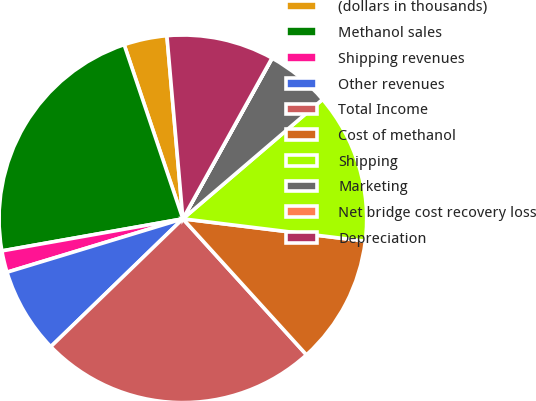<chart> <loc_0><loc_0><loc_500><loc_500><pie_chart><fcel>(dollars in thousands)<fcel>Methanol sales<fcel>Shipping revenues<fcel>Other revenues<fcel>Total Income<fcel>Cost of methanol<fcel>Shipping<fcel>Marketing<fcel>Net bridge cost recovery loss<fcel>Depreciation<nl><fcel>3.79%<fcel>22.62%<fcel>1.9%<fcel>7.55%<fcel>24.5%<fcel>11.32%<fcel>13.2%<fcel>5.67%<fcel>0.02%<fcel>9.44%<nl></chart> 